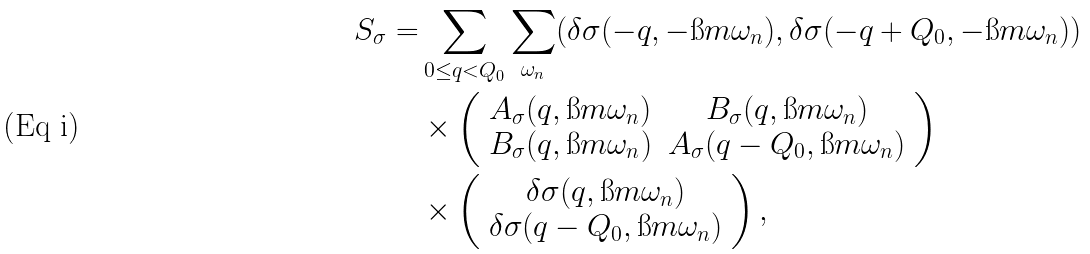Convert formula to latex. <formula><loc_0><loc_0><loc_500><loc_500>S _ { \sigma } = & \sum _ { 0 \leq q < Q _ { 0 } } \sum _ { \omega _ { n } } ( \delta \sigma ( - q , - \i m \omega _ { n } ) , \delta \sigma ( - q + Q _ { 0 } , - \i m \omega _ { n } ) ) \\ & \times \left ( \begin{array} { c c } A _ { \sigma } ( q , \i m \omega _ { n } ) & B _ { \sigma } ( q , \i m \omega _ { n } ) \\ B _ { \sigma } ( q , \i m \omega _ { n } ) & A _ { \sigma } ( q - Q _ { 0 } , \i m \omega _ { n } ) \end{array} \right ) \\ & \times \left ( \begin{array} { c } \delta \sigma ( q , \i m \omega _ { n } ) \\ \delta \sigma ( q - Q _ { 0 } , \i m \omega _ { n } ) \end{array} \right ) ,</formula> 